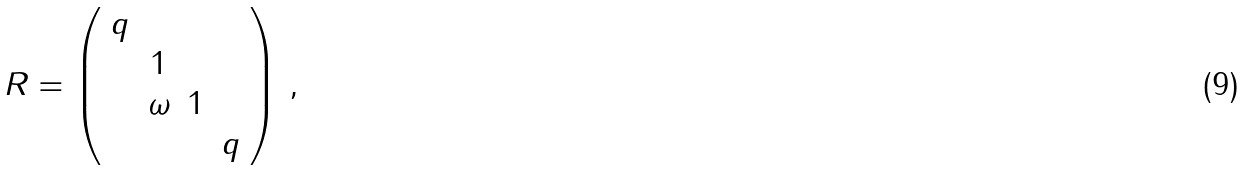Convert formula to latex. <formula><loc_0><loc_0><loc_500><loc_500>R = \left ( \begin{array} { c c c c } q & & & \\ & 1 & & \\ & \omega & 1 & \\ & & & q \end{array} \right ) \, ,</formula> 